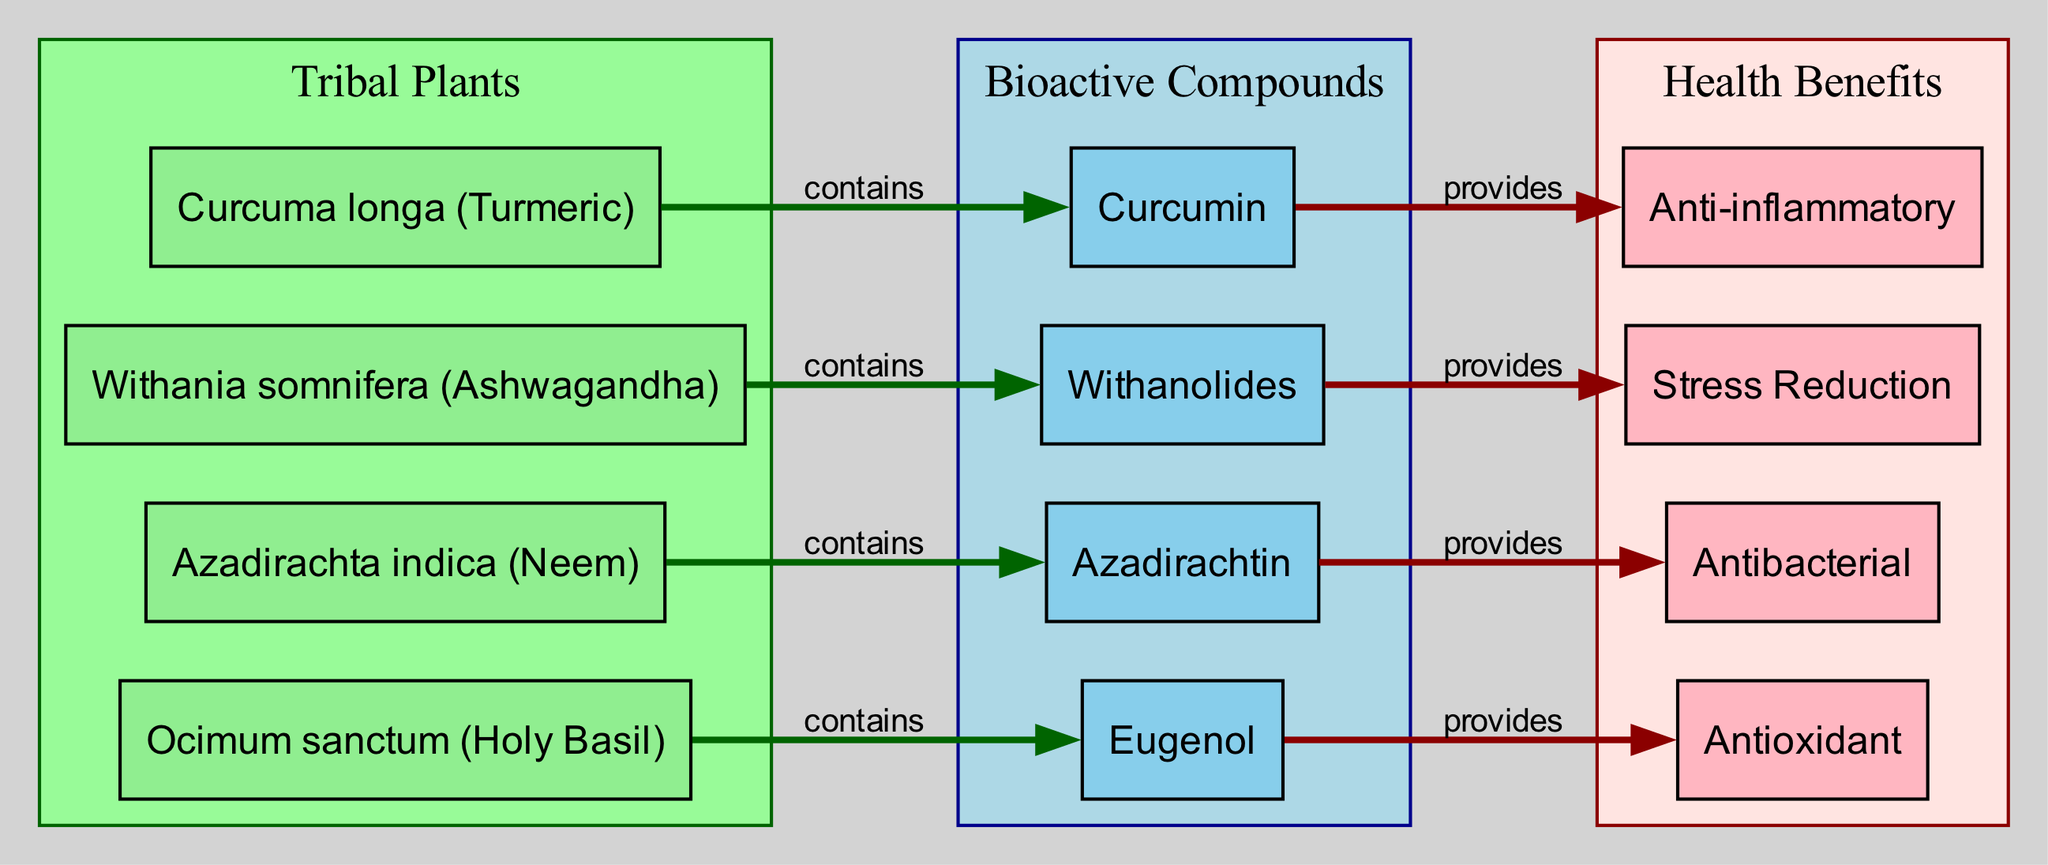What tribal plant contains Curcumin? The diagram shows a connection between "Curcuma longa (Turmeric)" and "Curcumin" with the label "contains" indicating that this plant is the source of the bioactive compound.
Answer: Curcuma longa (Turmeric) What is the health benefit provided by Withanolides? The flow from "Withania somnifera (Ashwagandha)" to "Withanolides" and then from "Withanolides" to "Stress Reduction" indicates that Withanolides provide the health benefit of Stress Reduction.
Answer: Stress Reduction How many bioactive compounds are shown in the diagram? By counting the nodes labeled as "bioactive compounds," we find there are four: Curcumin, Withanolides, Azadirachtin, and Eugenol.
Answer: 4 Which health benefit is associated with Azadirachtin? The edge from "Azadirachta indica (Neem)" to "Azadirachtin" and subsequently to "Antibacterial" shows that the health benefit associated with Azadirachtin is Antibacterial.
Answer: Antibacterial Identify the shortest connection in terms of steps from a tribal plant to a health benefit. Tracing the edges, the shortest path is from "Curcuma longa (Turmeric)" to "Curcumin" to "Anti-inflammatory," which only requires two steps.
Answer: 2 steps What color represents the bioactive compounds in the diagram? In the diagram, the subgraph for bioactive compounds is filled with "lightblue," making this the color associated with them.
Answer: lightblue Which tribal plant is associated with an antioxidant benefit? The connection from "Ocimum sanctum (Holy Basil)" leads to "Eugenol," which provides the health benefit of Antioxidant as indicated on the edge.
Answer: Ocimum sanctum (Holy Basil) What does the label on the edge between "bioactiveCompound3" and "healthBenefit3" signify? The edge label "provides" indicates that Azadirachtin delivers a specific health benefit as shown by the link flowing from "bioactiveCompound3" to "healthBenefit3."
Answer: provides What is the relationship between "Ocimum sanctum (Holy Basil)" and "Eugenol"? The diagram states that "Ocimum sanctum (Holy Basil)" contains "Eugenol," shown by the connection labeled "contains."
Answer: contains 